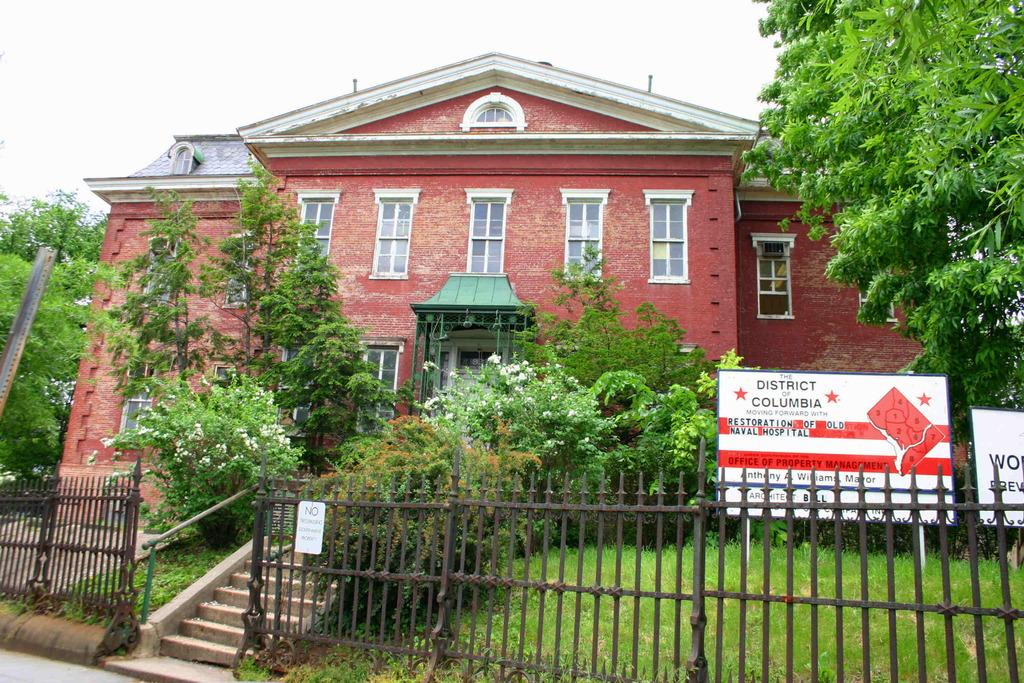What type of structure can be seen in the image? There is a rail in the image. What type of natural environment is visible in the image? There is grass and trees visible in the image. What is written on the board in the image? There is a board with written text on the right side of the image. What type of building can be seen in the background of the image? There is a house in the background of the image. What type of cheese is being used to decorate the trees in the image? There is no cheese present in the image; it features a rail, grass, trees, a board with text, and a house in the background. 